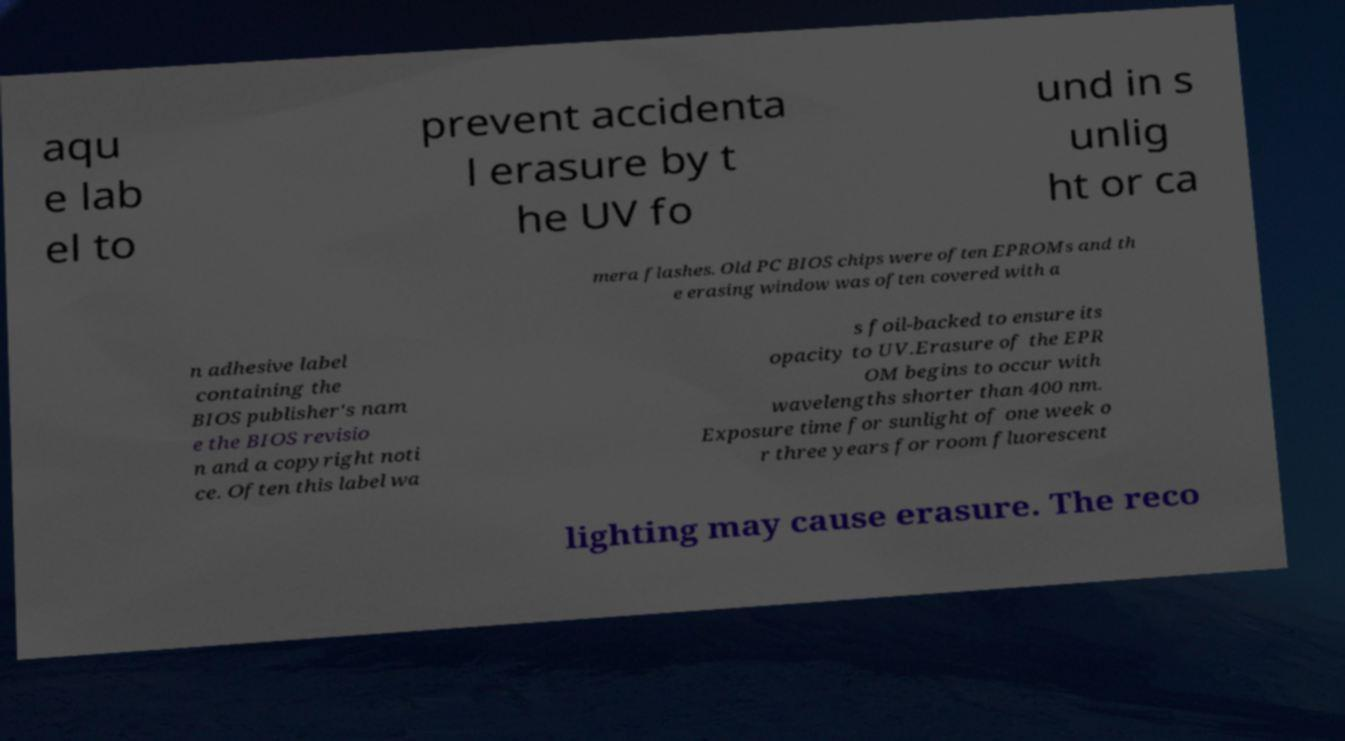Can you read and provide the text displayed in the image?This photo seems to have some interesting text. Can you extract and type it out for me? aqu e lab el to prevent accidenta l erasure by t he UV fo und in s unlig ht or ca mera flashes. Old PC BIOS chips were often EPROMs and th e erasing window was often covered with a n adhesive label containing the BIOS publisher's nam e the BIOS revisio n and a copyright noti ce. Often this label wa s foil-backed to ensure its opacity to UV.Erasure of the EPR OM begins to occur with wavelengths shorter than 400 nm. Exposure time for sunlight of one week o r three years for room fluorescent lighting may cause erasure. The reco 